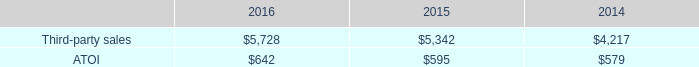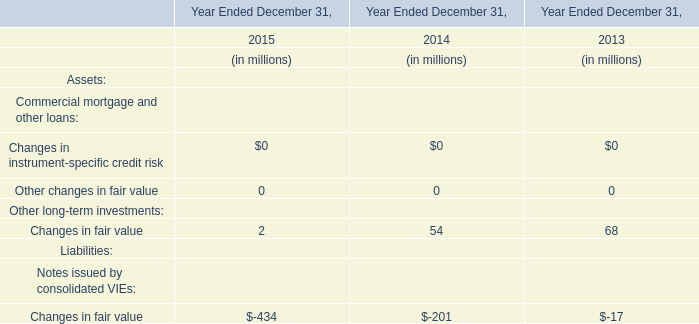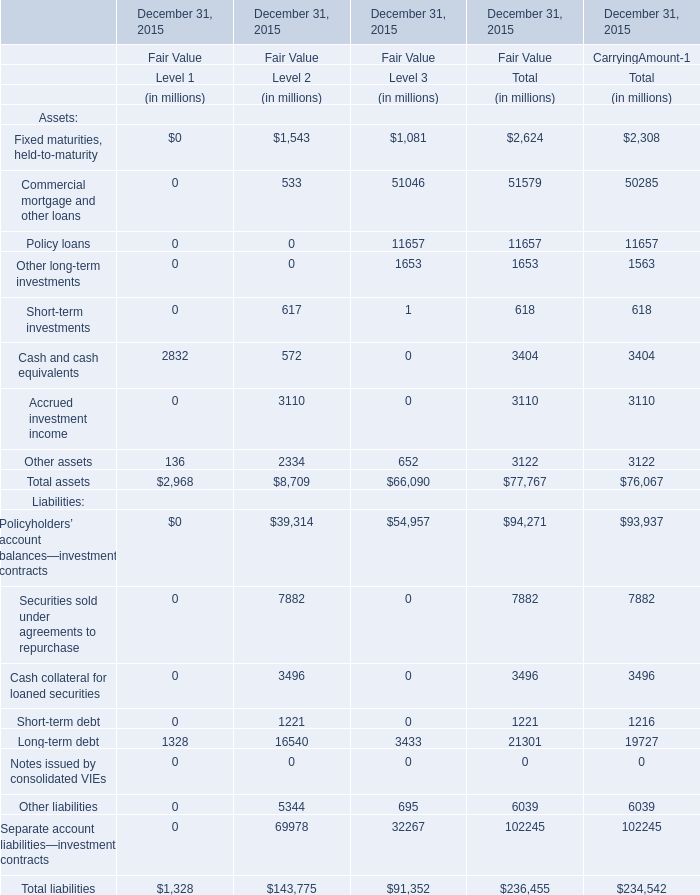considering the year 2014 , how bigger were the number of dollars received from sales generated from firth rixson in comparison with tital? 
Computations: (((970 / 100) * 100) - 100)
Answer: 870.0. 